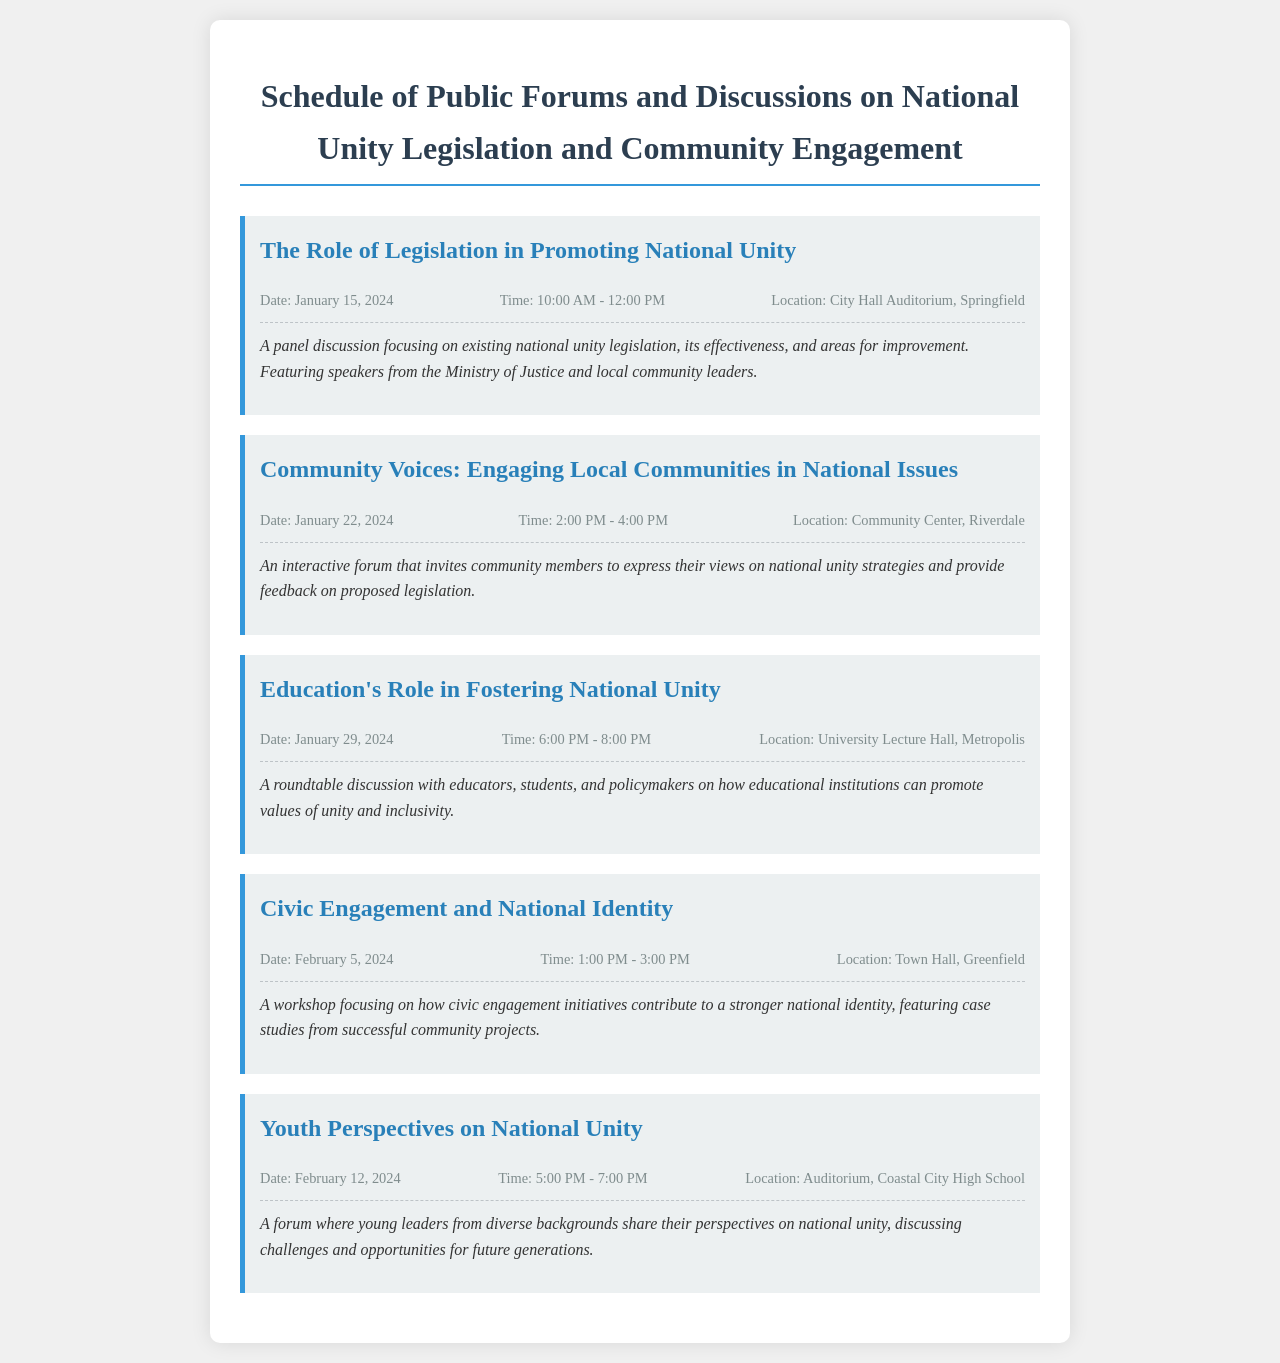What is the first event listed in the schedule? The first event is the one with the title "The Role of Legislation in Promoting National Unity."
Answer: The Role of Legislation in Promoting National Unity What is the date of the last event? The last event is scheduled for February 12, 2024.
Answer: February 12, 2024 Where is the event on Community Voices being held? The event is taking place at the Community Center, Riverdale.
Answer: Community Center, Riverdale What time does the Youth Perspectives event begin? The Youth Perspectives event begins at 5:00 PM.
Answer: 5:00 PM How many events are scheduled in total? There are five events listed in the document.
Answer: Five What is the common theme of all events in the schedule? All events focus on the theme of national unity and community engagement.
Answer: National unity and community engagement Which organization is represented in the first event's panel discussion? The panel discussion includes speakers from the Ministry of Justice.
Answer: Ministry of Justice What type of event is the discussion on Education's Role? It is a roundtable discussion.
Answer: Roundtable discussion What is a common activity mentioned in the Community Voices event? The event invites community members to express their views.
Answer: Express their views 